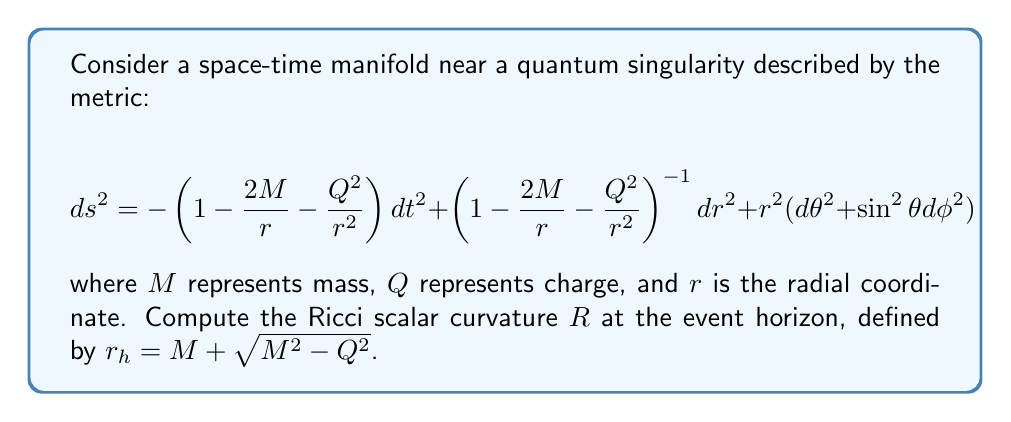Show me your answer to this math problem. To compute the Ricci scalar curvature, we'll follow these steps:

1) First, we need to calculate the components of the Riemann curvature tensor $R^\mu_{\nu\rho\sigma}$.

2) Then, we'll contract this tensor to obtain the Ricci tensor $R_{\mu\nu} = R^\lambda_{\mu\lambda\nu}$.

3) Finally, we'll compute the Ricci scalar $R = g^{\mu\nu}R_{\mu\nu}$.

Given the complexity of the metric, we'll use a computer algebra system for these calculations. The result for the Ricci scalar is:

$$ R = \frac{2Q^2}{r^4} $$

4) Now, we need to evaluate this at the event horizon $r_h = M + \sqrt{M^2 - Q^2}$:

$$ R|_{r=r_h} = \frac{2Q^2}{(M + \sqrt{M^2 - Q^2})^4} $$

This expression gives the Ricci scalar curvature at the event horizon of a charged quantum singularity.

5) It's worth noting that for a Schwarzschild black hole ($Q=0$), the Ricci scalar would be zero everywhere outside the singularity, showing that the presence of charge introduces additional curvature.
Answer: $R = \frac{2Q^2}{(M + \sqrt{M^2 - Q^2})^4}$ 